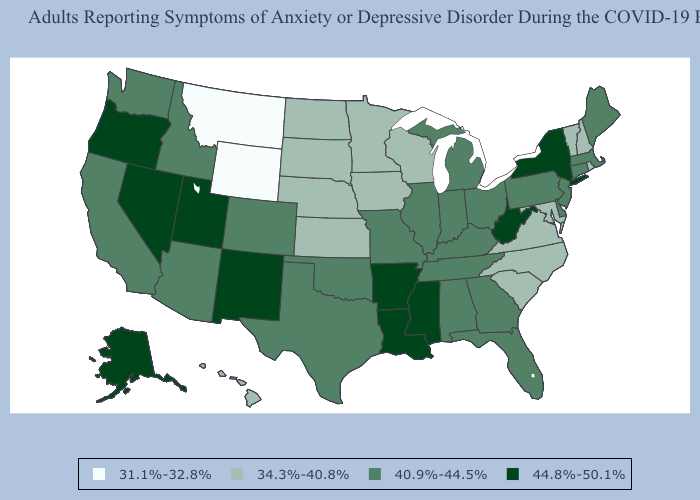Is the legend a continuous bar?
Write a very short answer. No. What is the value of Alabama?
Concise answer only. 40.9%-44.5%. What is the value of South Carolina?
Keep it brief. 34.3%-40.8%. Name the states that have a value in the range 44.8%-50.1%?
Quick response, please. Alaska, Arkansas, Louisiana, Mississippi, Nevada, New Mexico, New York, Oregon, Utah, West Virginia. What is the lowest value in the Northeast?
Keep it brief. 34.3%-40.8%. Which states have the highest value in the USA?
Concise answer only. Alaska, Arkansas, Louisiana, Mississippi, Nevada, New Mexico, New York, Oregon, Utah, West Virginia. Among the states that border Wyoming , which have the highest value?
Write a very short answer. Utah. Does Kansas have a lower value than Idaho?
Answer briefly. Yes. How many symbols are there in the legend?
Quick response, please. 4. Which states have the lowest value in the South?
Concise answer only. Maryland, North Carolina, South Carolina, Virginia. Among the states that border Wisconsin , does Michigan have the lowest value?
Keep it brief. No. What is the value of New York?
Answer briefly. 44.8%-50.1%. What is the value of South Carolina?
Keep it brief. 34.3%-40.8%. Name the states that have a value in the range 44.8%-50.1%?
Answer briefly. Alaska, Arkansas, Louisiana, Mississippi, Nevada, New Mexico, New York, Oregon, Utah, West Virginia. 